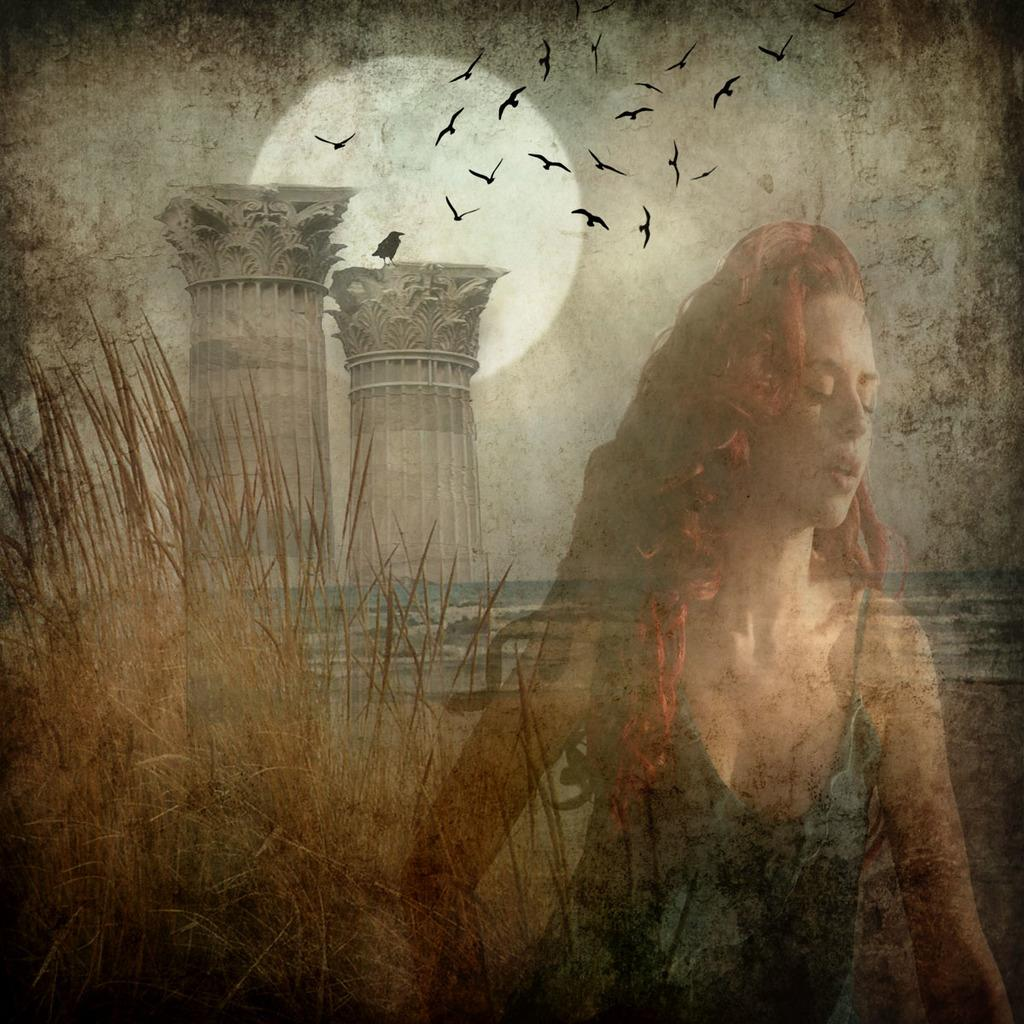What type of animals are featured in the painting? The painting contains birds. What natural element is depicted in the painting? The painting depicts the sky. What architectural feature is present in the painting? There are pillars in the painting. What type of vegetation is included in the painting? Grass is present in the painting. What body of water is shown in the painting? The painting includes a sea. What geological feature is visible in the painting? Rocks are visible in the painting. Are there any human figures in the painting? Yes, there is a woman in the painting. What book is the woman reading in the painting? There is no book present in the painting; the woman is not depicted reading. What type of humor is being used in the painting? There is no humor present in the painting; it is a serious depiction of the scene. 